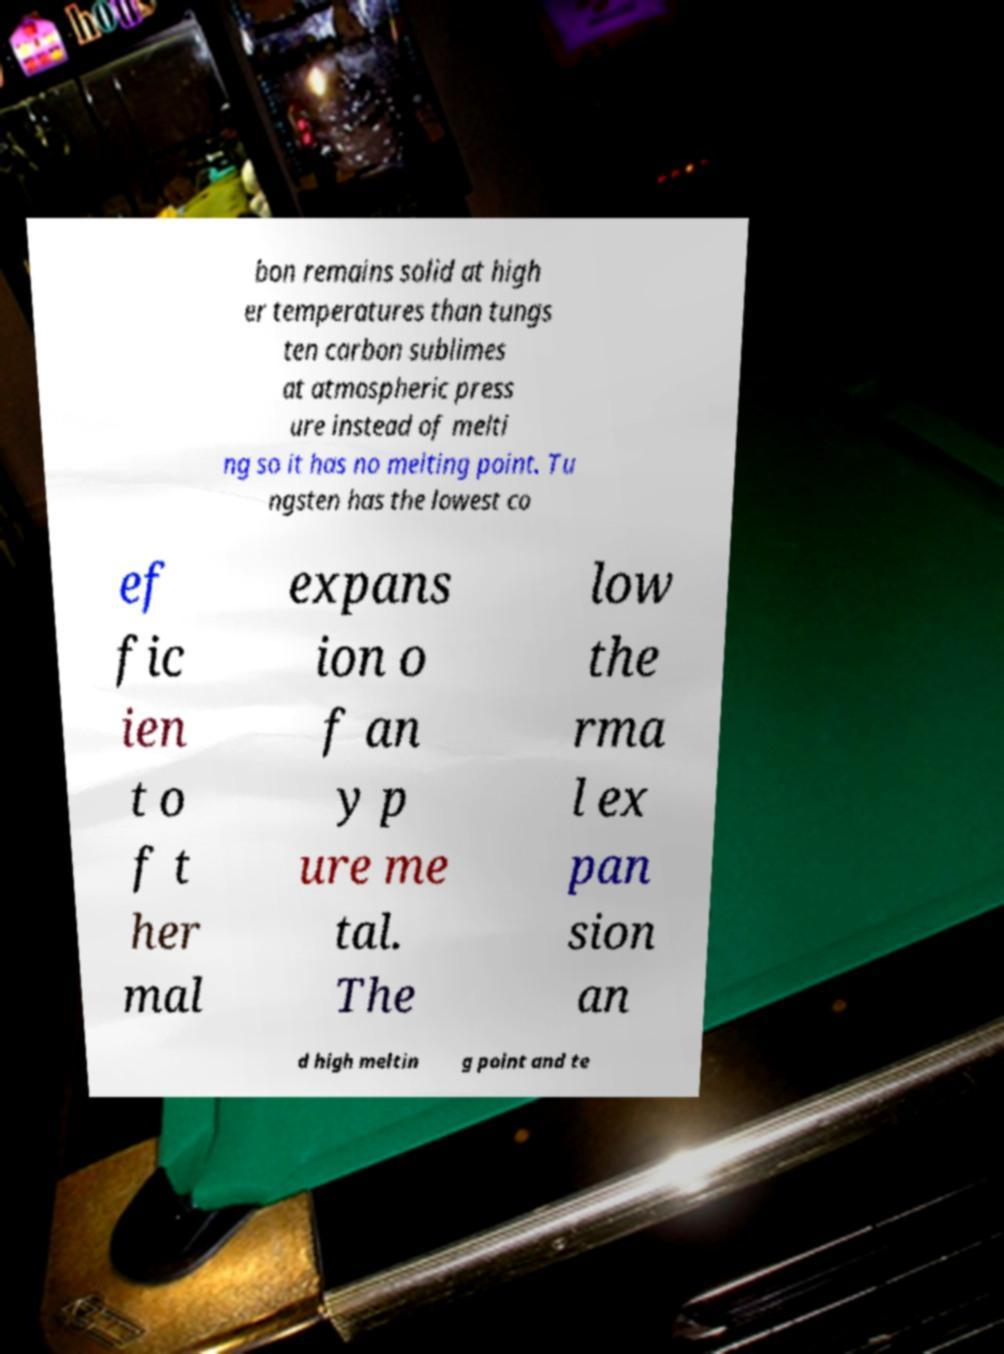For documentation purposes, I need the text within this image transcribed. Could you provide that? bon remains solid at high er temperatures than tungs ten carbon sublimes at atmospheric press ure instead of melti ng so it has no melting point. Tu ngsten has the lowest co ef fic ien t o f t her mal expans ion o f an y p ure me tal. The low the rma l ex pan sion an d high meltin g point and te 